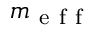Convert formula to latex. <formula><loc_0><loc_0><loc_500><loc_500>m _ { e f f }</formula> 